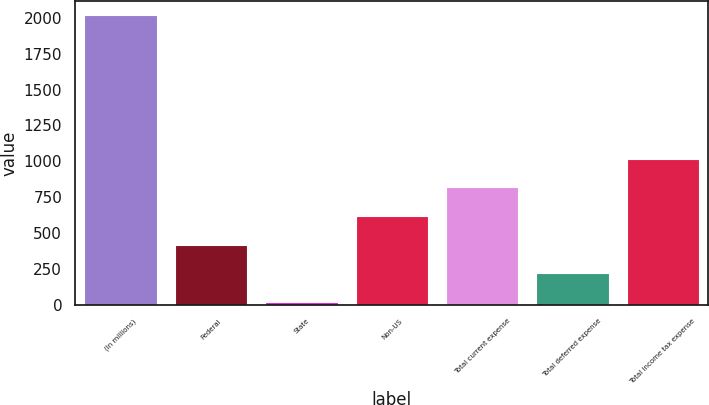<chart> <loc_0><loc_0><loc_500><loc_500><bar_chart><fcel>(In millions)<fcel>Federal<fcel>State<fcel>Non-US<fcel>Total current expense<fcel>Total deferred expense<fcel>Total income tax expense<nl><fcel>2017<fcel>417.8<fcel>18<fcel>617.7<fcel>817.6<fcel>217.9<fcel>1017.5<nl></chart> 